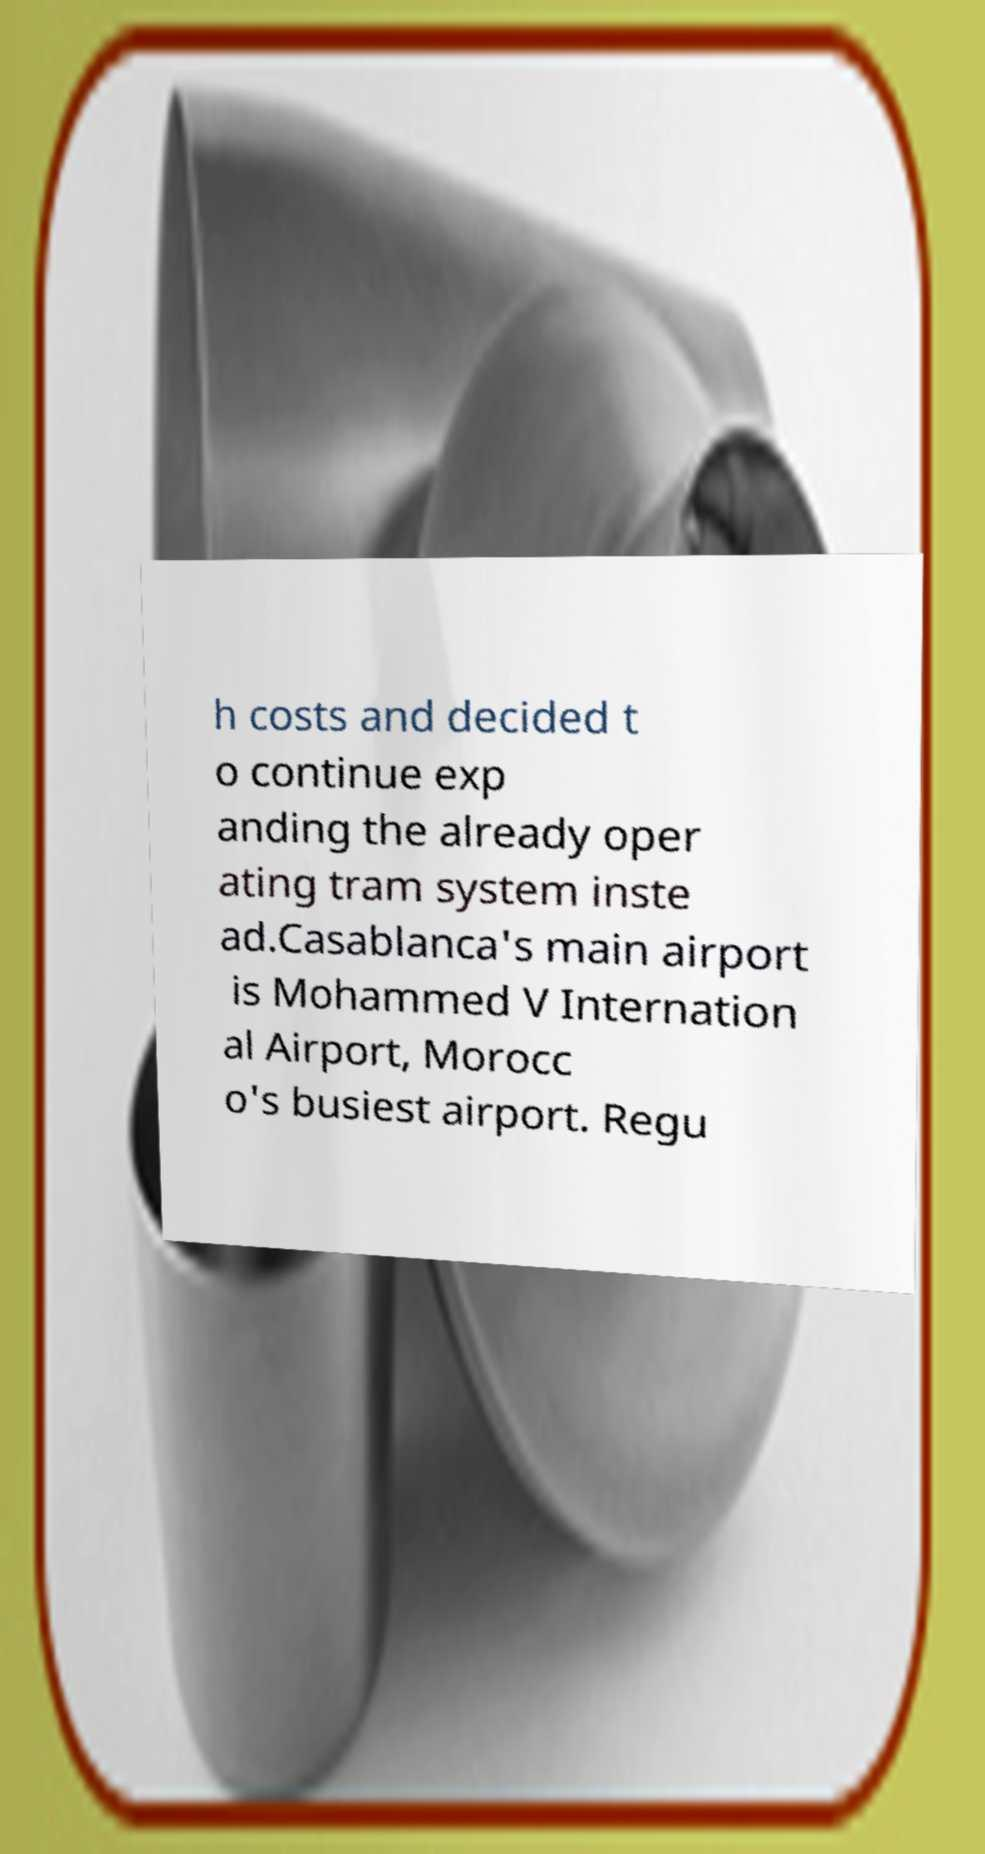What messages or text are displayed in this image? I need them in a readable, typed format. h costs and decided t o continue exp anding the already oper ating tram system inste ad.Casablanca's main airport is Mohammed V Internation al Airport, Morocc o's busiest airport. Regu 